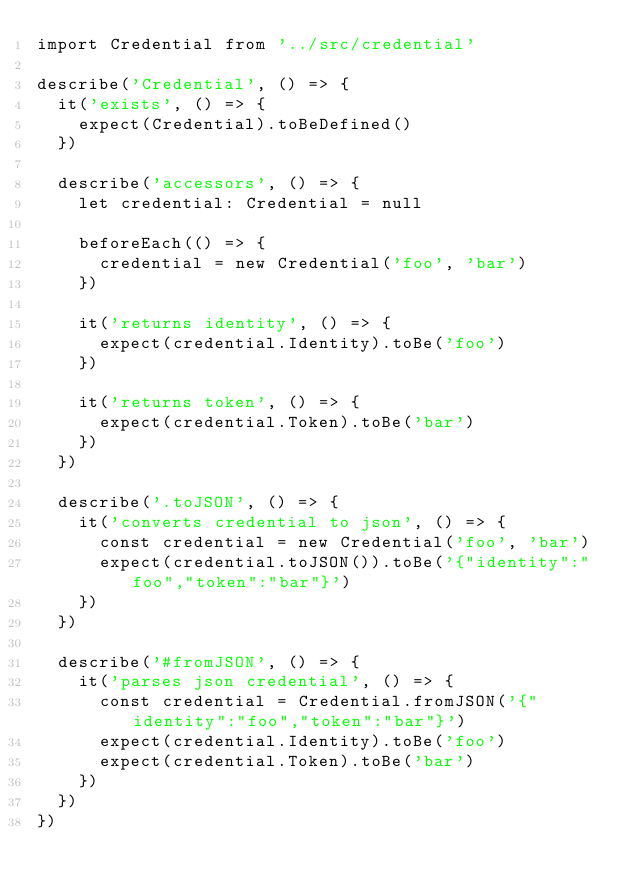<code> <loc_0><loc_0><loc_500><loc_500><_TypeScript_>import Credential from '../src/credential'

describe('Credential', () => {
  it('exists', () => {
    expect(Credential).toBeDefined()
  })

  describe('accessors', () => {
    let credential: Credential = null

    beforeEach(() => {
      credential = new Credential('foo', 'bar')
    })

    it('returns identity', () => {
      expect(credential.Identity).toBe('foo')
    })

    it('returns token', () => {
      expect(credential.Token).toBe('bar')
    })
  })

  describe('.toJSON', () => {
    it('converts credential to json', () => {
      const credential = new Credential('foo', 'bar')
      expect(credential.toJSON()).toBe('{"identity":"foo","token":"bar"}')
    })
  })

  describe('#fromJSON', () => {
    it('parses json credential', () => {
      const credential = Credential.fromJSON('{"identity":"foo","token":"bar"}')
      expect(credential.Identity).toBe('foo')
      expect(credential.Token).toBe('bar')
    })
  })
})
</code> 